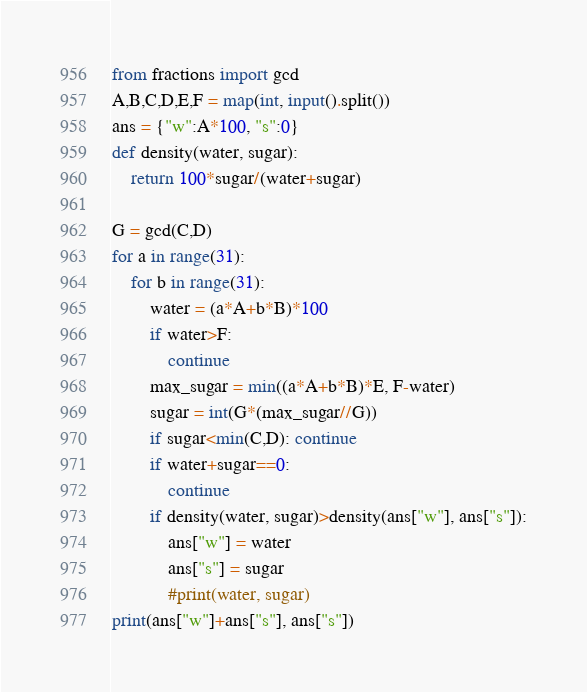Convert code to text. <code><loc_0><loc_0><loc_500><loc_500><_Python_>from fractions import gcd
A,B,C,D,E,F = map(int, input().split())
ans = {"w":A*100, "s":0}
def density(water, sugar):
    return 100*sugar/(water+sugar)

G = gcd(C,D)
for a in range(31):
    for b in range(31):
        water = (a*A+b*B)*100
        if water>F:
            continue
        max_sugar = min((a*A+b*B)*E, F-water)
        sugar = int(G*(max_sugar//G))
        if sugar<min(C,D): continue
        if water+sugar==0: 
            continue
        if density(water, sugar)>density(ans["w"], ans["s"]):
            ans["w"] = water
            ans["s"] = sugar
            #print(water, sugar)
print(ans["w"]+ans["s"], ans["s"])</code> 